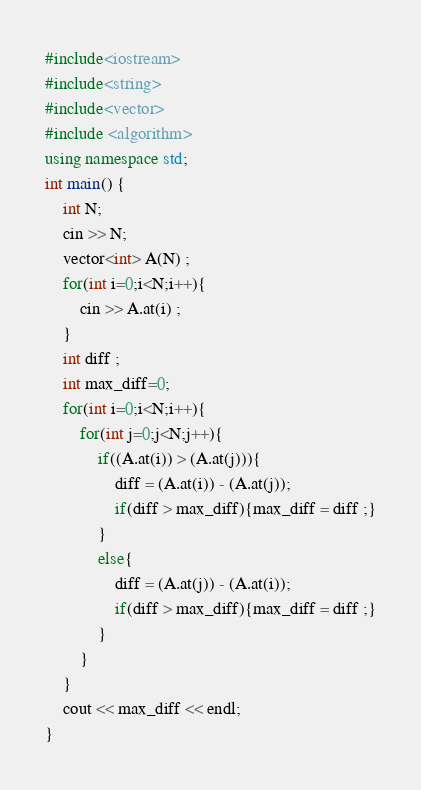<code> <loc_0><loc_0><loc_500><loc_500><_C++_>#include<iostream>
#include<string>
#include<vector>
#include <algorithm>
using namespace std;
int main() {
    int N;
    cin >> N;
    vector<int> A(N) ;
    for(int i=0;i<N;i++){
        cin >> A.at(i) ;
    }
    int diff ;
    int max_diff=0;
    for(int i=0;i<N;i++){
        for(int j=0;j<N;j++){
            if((A.at(i)) > (A.at(j))){
                diff = (A.at(i)) - (A.at(j));
                if(diff > max_diff){max_diff = diff ;}
            }
            else{
                diff = (A.at(j)) - (A.at(i));
                if(diff > max_diff){max_diff = diff ;}
            }
        }
    }
    cout << max_diff << endl;
}</code> 